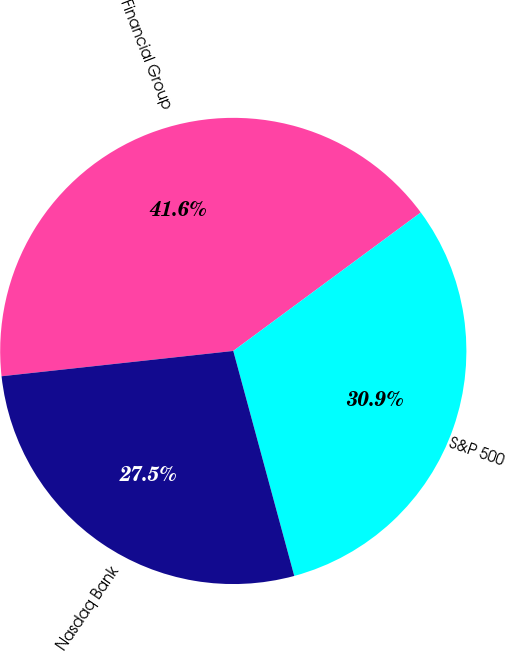Convert chart to OTSL. <chart><loc_0><loc_0><loc_500><loc_500><pie_chart><fcel>SVB Financial Group<fcel>S&P 500<fcel>Nasdaq Bank<nl><fcel>41.61%<fcel>30.91%<fcel>27.48%<nl></chart> 